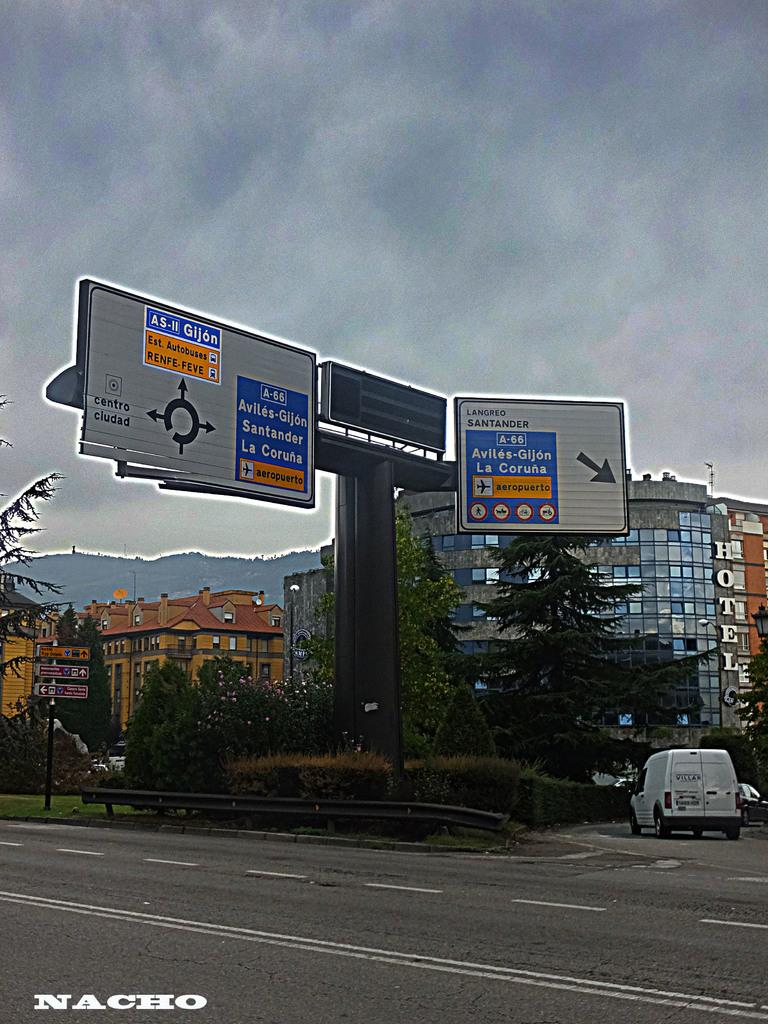Provide a one-sentence caption for the provided image. The sign over a highway directs those going to La Coruna to get in the right lane. 